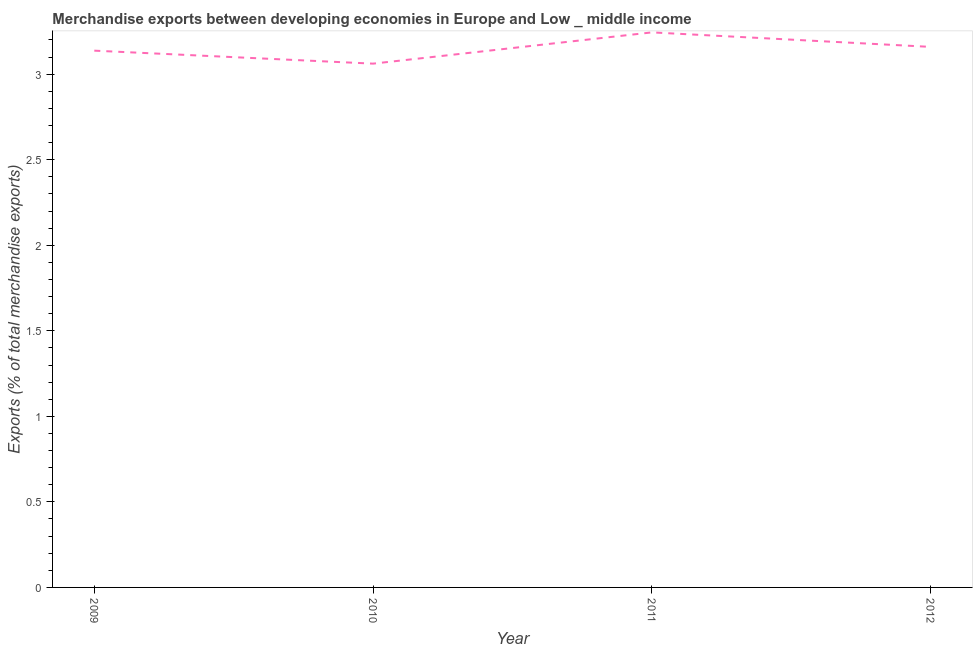What is the merchandise exports in 2012?
Provide a succinct answer. 3.16. Across all years, what is the maximum merchandise exports?
Your answer should be compact. 3.24. Across all years, what is the minimum merchandise exports?
Your answer should be very brief. 3.06. In which year was the merchandise exports maximum?
Ensure brevity in your answer.  2011. In which year was the merchandise exports minimum?
Your answer should be very brief. 2010. What is the sum of the merchandise exports?
Your answer should be very brief. 12.6. What is the difference between the merchandise exports in 2009 and 2012?
Offer a very short reply. -0.02. What is the average merchandise exports per year?
Offer a terse response. 3.15. What is the median merchandise exports?
Give a very brief answer. 3.15. In how many years, is the merchandise exports greater than 0.9 %?
Make the answer very short. 4. Do a majority of the years between 2009 and 2011 (inclusive) have merchandise exports greater than 2.9 %?
Ensure brevity in your answer.  Yes. What is the ratio of the merchandise exports in 2011 to that in 2012?
Give a very brief answer. 1.03. Is the merchandise exports in 2010 less than that in 2011?
Provide a short and direct response. Yes. Is the difference between the merchandise exports in 2010 and 2011 greater than the difference between any two years?
Give a very brief answer. Yes. What is the difference between the highest and the second highest merchandise exports?
Your answer should be very brief. 0.08. Is the sum of the merchandise exports in 2010 and 2011 greater than the maximum merchandise exports across all years?
Provide a short and direct response. Yes. What is the difference between the highest and the lowest merchandise exports?
Make the answer very short. 0.18. In how many years, is the merchandise exports greater than the average merchandise exports taken over all years?
Offer a terse response. 2. How many lines are there?
Offer a terse response. 1. How many years are there in the graph?
Offer a terse response. 4. Are the values on the major ticks of Y-axis written in scientific E-notation?
Ensure brevity in your answer.  No. Does the graph contain grids?
Provide a succinct answer. No. What is the title of the graph?
Your answer should be compact. Merchandise exports between developing economies in Europe and Low _ middle income. What is the label or title of the Y-axis?
Your answer should be compact. Exports (% of total merchandise exports). What is the Exports (% of total merchandise exports) in 2009?
Provide a succinct answer. 3.14. What is the Exports (% of total merchandise exports) of 2010?
Offer a very short reply. 3.06. What is the Exports (% of total merchandise exports) of 2011?
Your answer should be compact. 3.24. What is the Exports (% of total merchandise exports) in 2012?
Your response must be concise. 3.16. What is the difference between the Exports (% of total merchandise exports) in 2009 and 2010?
Make the answer very short. 0.08. What is the difference between the Exports (% of total merchandise exports) in 2009 and 2011?
Your answer should be very brief. -0.11. What is the difference between the Exports (% of total merchandise exports) in 2009 and 2012?
Keep it short and to the point. -0.02. What is the difference between the Exports (% of total merchandise exports) in 2010 and 2011?
Keep it short and to the point. -0.18. What is the difference between the Exports (% of total merchandise exports) in 2010 and 2012?
Offer a very short reply. -0.1. What is the difference between the Exports (% of total merchandise exports) in 2011 and 2012?
Provide a short and direct response. 0.08. What is the ratio of the Exports (% of total merchandise exports) in 2009 to that in 2012?
Your answer should be compact. 0.99. What is the ratio of the Exports (% of total merchandise exports) in 2010 to that in 2011?
Make the answer very short. 0.94. What is the ratio of the Exports (% of total merchandise exports) in 2010 to that in 2012?
Offer a terse response. 0.97. 